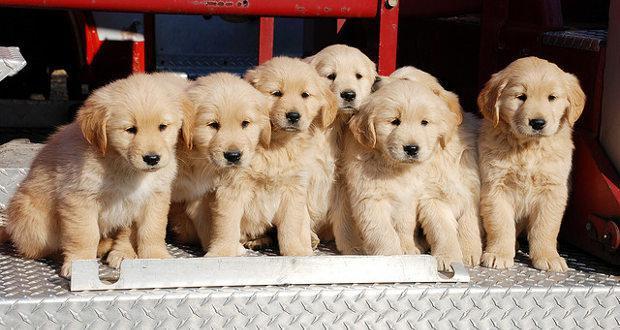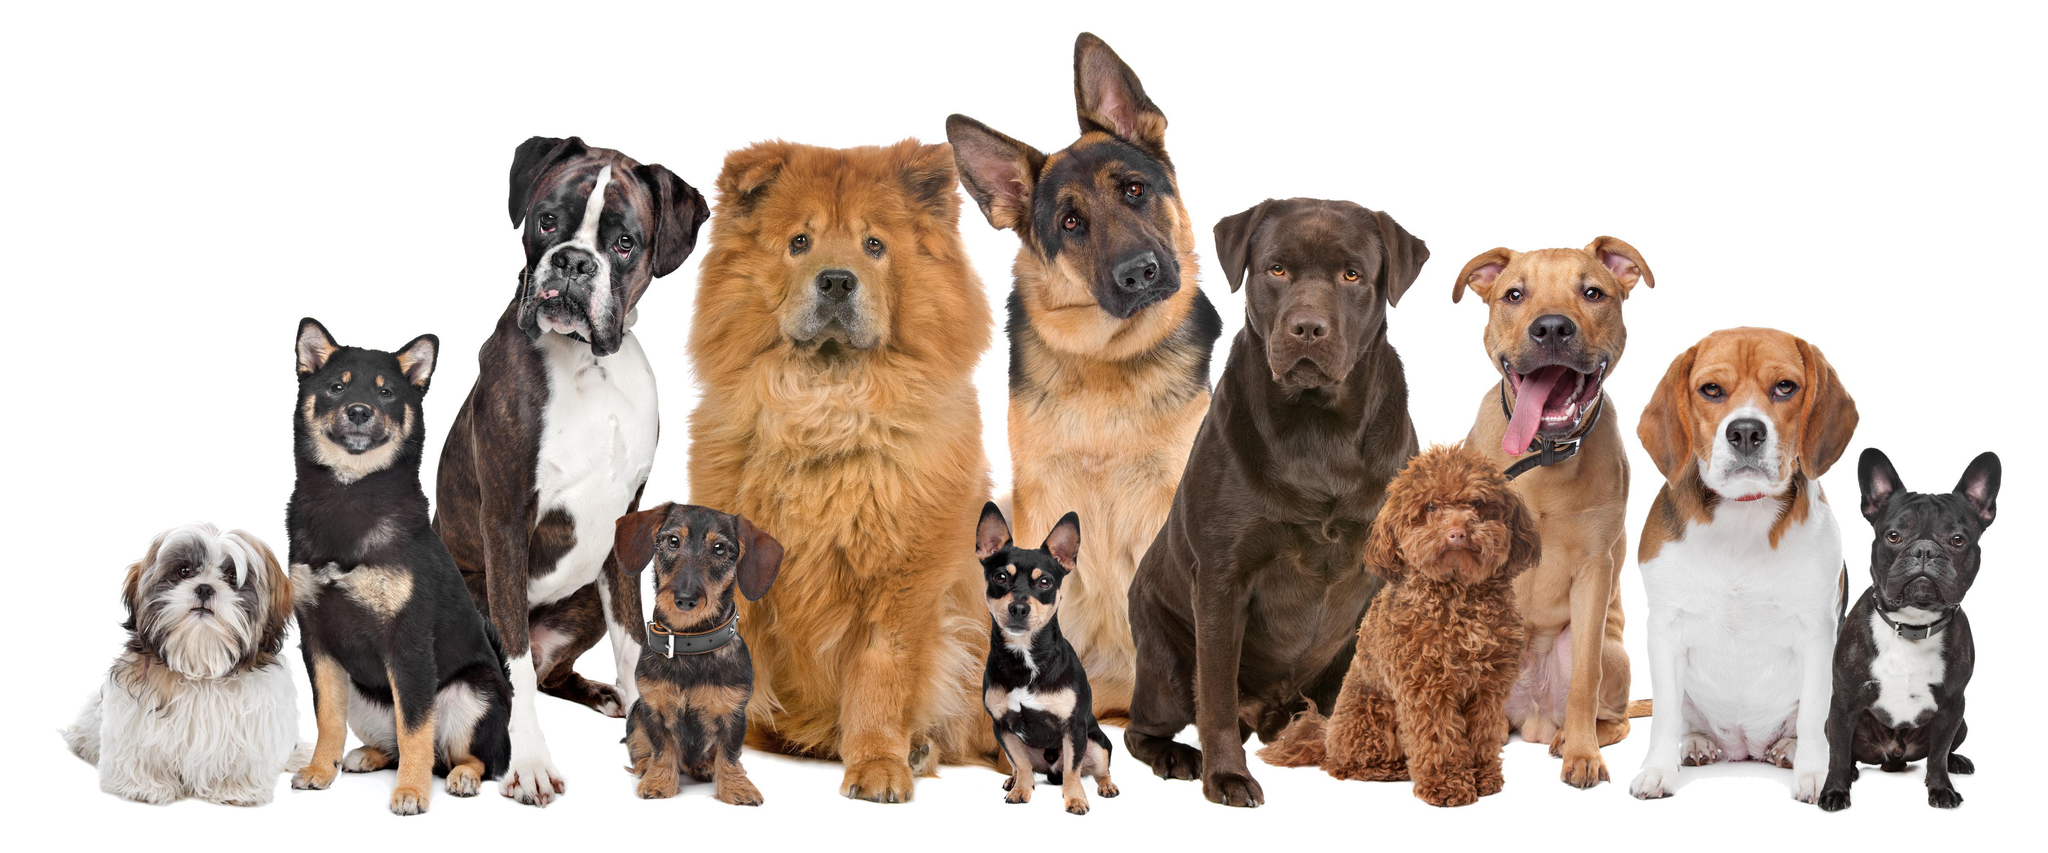The first image is the image on the left, the second image is the image on the right. Examine the images to the left and right. Is the description "One of the images in the pair contains at least ten dogs." accurate? Answer yes or no. Yes. 